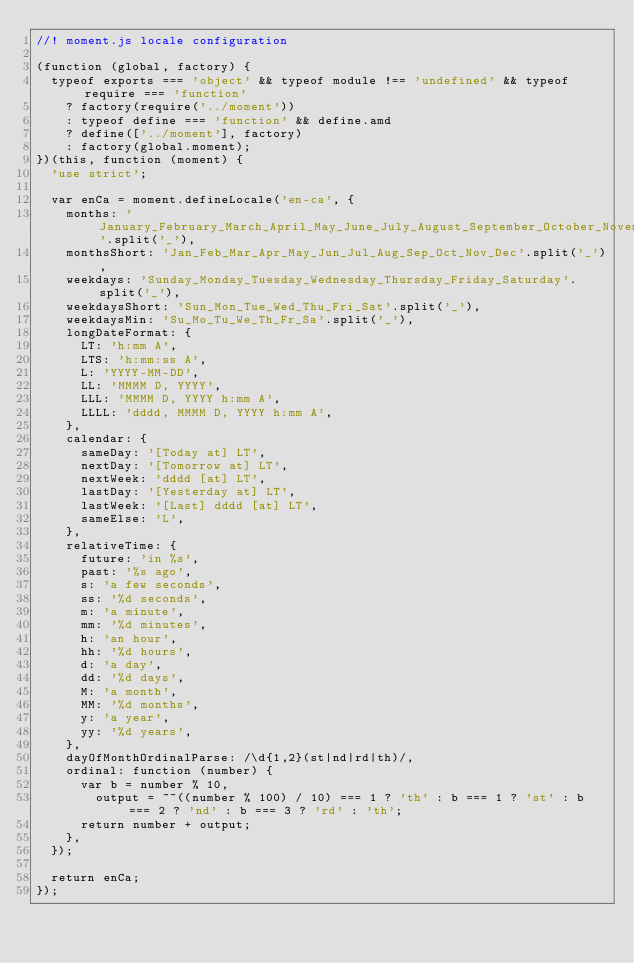<code> <loc_0><loc_0><loc_500><loc_500><_JavaScript_>//! moment.js locale configuration

(function (global, factory) {
  typeof exports === 'object' && typeof module !== 'undefined' && typeof require === 'function'
    ? factory(require('../moment'))
    : typeof define === 'function' && define.amd
    ? define(['../moment'], factory)
    : factory(global.moment);
})(this, function (moment) {
  'use strict';

  var enCa = moment.defineLocale('en-ca', {
    months: 'January_February_March_April_May_June_July_August_September_October_November_December'.split('_'),
    monthsShort: 'Jan_Feb_Mar_Apr_May_Jun_Jul_Aug_Sep_Oct_Nov_Dec'.split('_'),
    weekdays: 'Sunday_Monday_Tuesday_Wednesday_Thursday_Friday_Saturday'.split('_'),
    weekdaysShort: 'Sun_Mon_Tue_Wed_Thu_Fri_Sat'.split('_'),
    weekdaysMin: 'Su_Mo_Tu_We_Th_Fr_Sa'.split('_'),
    longDateFormat: {
      LT: 'h:mm A',
      LTS: 'h:mm:ss A',
      L: 'YYYY-MM-DD',
      LL: 'MMMM D, YYYY',
      LLL: 'MMMM D, YYYY h:mm A',
      LLLL: 'dddd, MMMM D, YYYY h:mm A',
    },
    calendar: {
      sameDay: '[Today at] LT',
      nextDay: '[Tomorrow at] LT',
      nextWeek: 'dddd [at] LT',
      lastDay: '[Yesterday at] LT',
      lastWeek: '[Last] dddd [at] LT',
      sameElse: 'L',
    },
    relativeTime: {
      future: 'in %s',
      past: '%s ago',
      s: 'a few seconds',
      ss: '%d seconds',
      m: 'a minute',
      mm: '%d minutes',
      h: 'an hour',
      hh: '%d hours',
      d: 'a day',
      dd: '%d days',
      M: 'a month',
      MM: '%d months',
      y: 'a year',
      yy: '%d years',
    },
    dayOfMonthOrdinalParse: /\d{1,2}(st|nd|rd|th)/,
    ordinal: function (number) {
      var b = number % 10,
        output = ~~((number % 100) / 10) === 1 ? 'th' : b === 1 ? 'st' : b === 2 ? 'nd' : b === 3 ? 'rd' : 'th';
      return number + output;
    },
  });

  return enCa;
});
</code> 